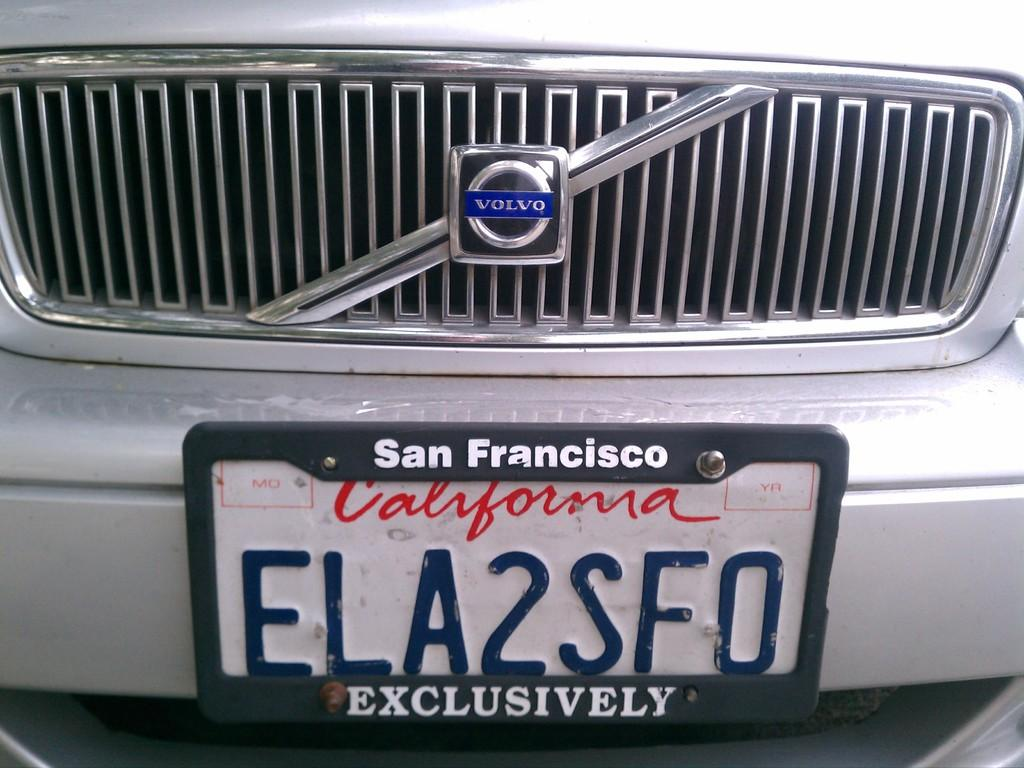<image>
Relay a brief, clear account of the picture shown. San Francisco license plate that says ELA2SF0 on it. 